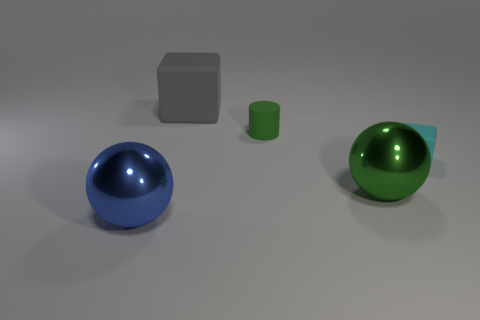Add 1 big red cubes. How many objects exist? 6 Subtract all spheres. How many objects are left? 3 Add 4 green spheres. How many green spheres are left? 5 Add 5 cylinders. How many cylinders exist? 6 Subtract 1 gray blocks. How many objects are left? 4 Subtract all large blue objects. Subtract all large cyan metallic cylinders. How many objects are left? 4 